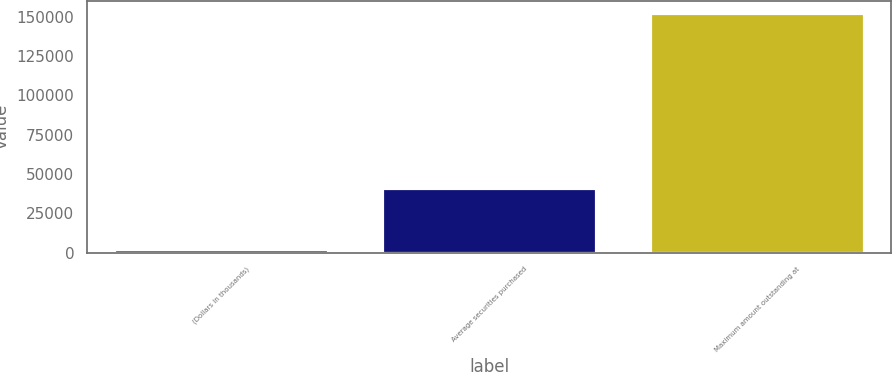Convert chart. <chart><loc_0><loc_0><loc_500><loc_500><bar_chart><fcel>(Dollars in thousands)<fcel>Average securities purchased<fcel>Maximum amount outstanding at<nl><fcel>2010<fcel>41113<fcel>152603<nl></chart> 